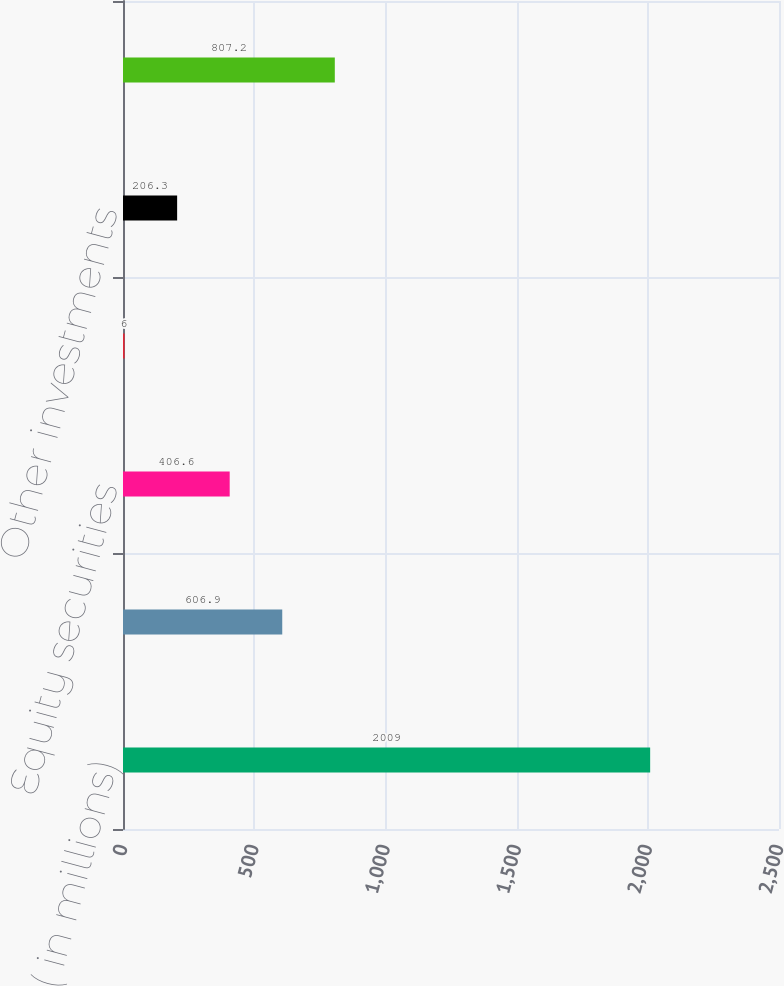Convert chart. <chart><loc_0><loc_0><loc_500><loc_500><bar_chart><fcel>( in millions)<fcel>Fixed income securities<fcel>Equity securities<fcel>Mortgage loans<fcel>Other investments<fcel>Change in intent write-downs<nl><fcel>2009<fcel>606.9<fcel>406.6<fcel>6<fcel>206.3<fcel>807.2<nl></chart> 